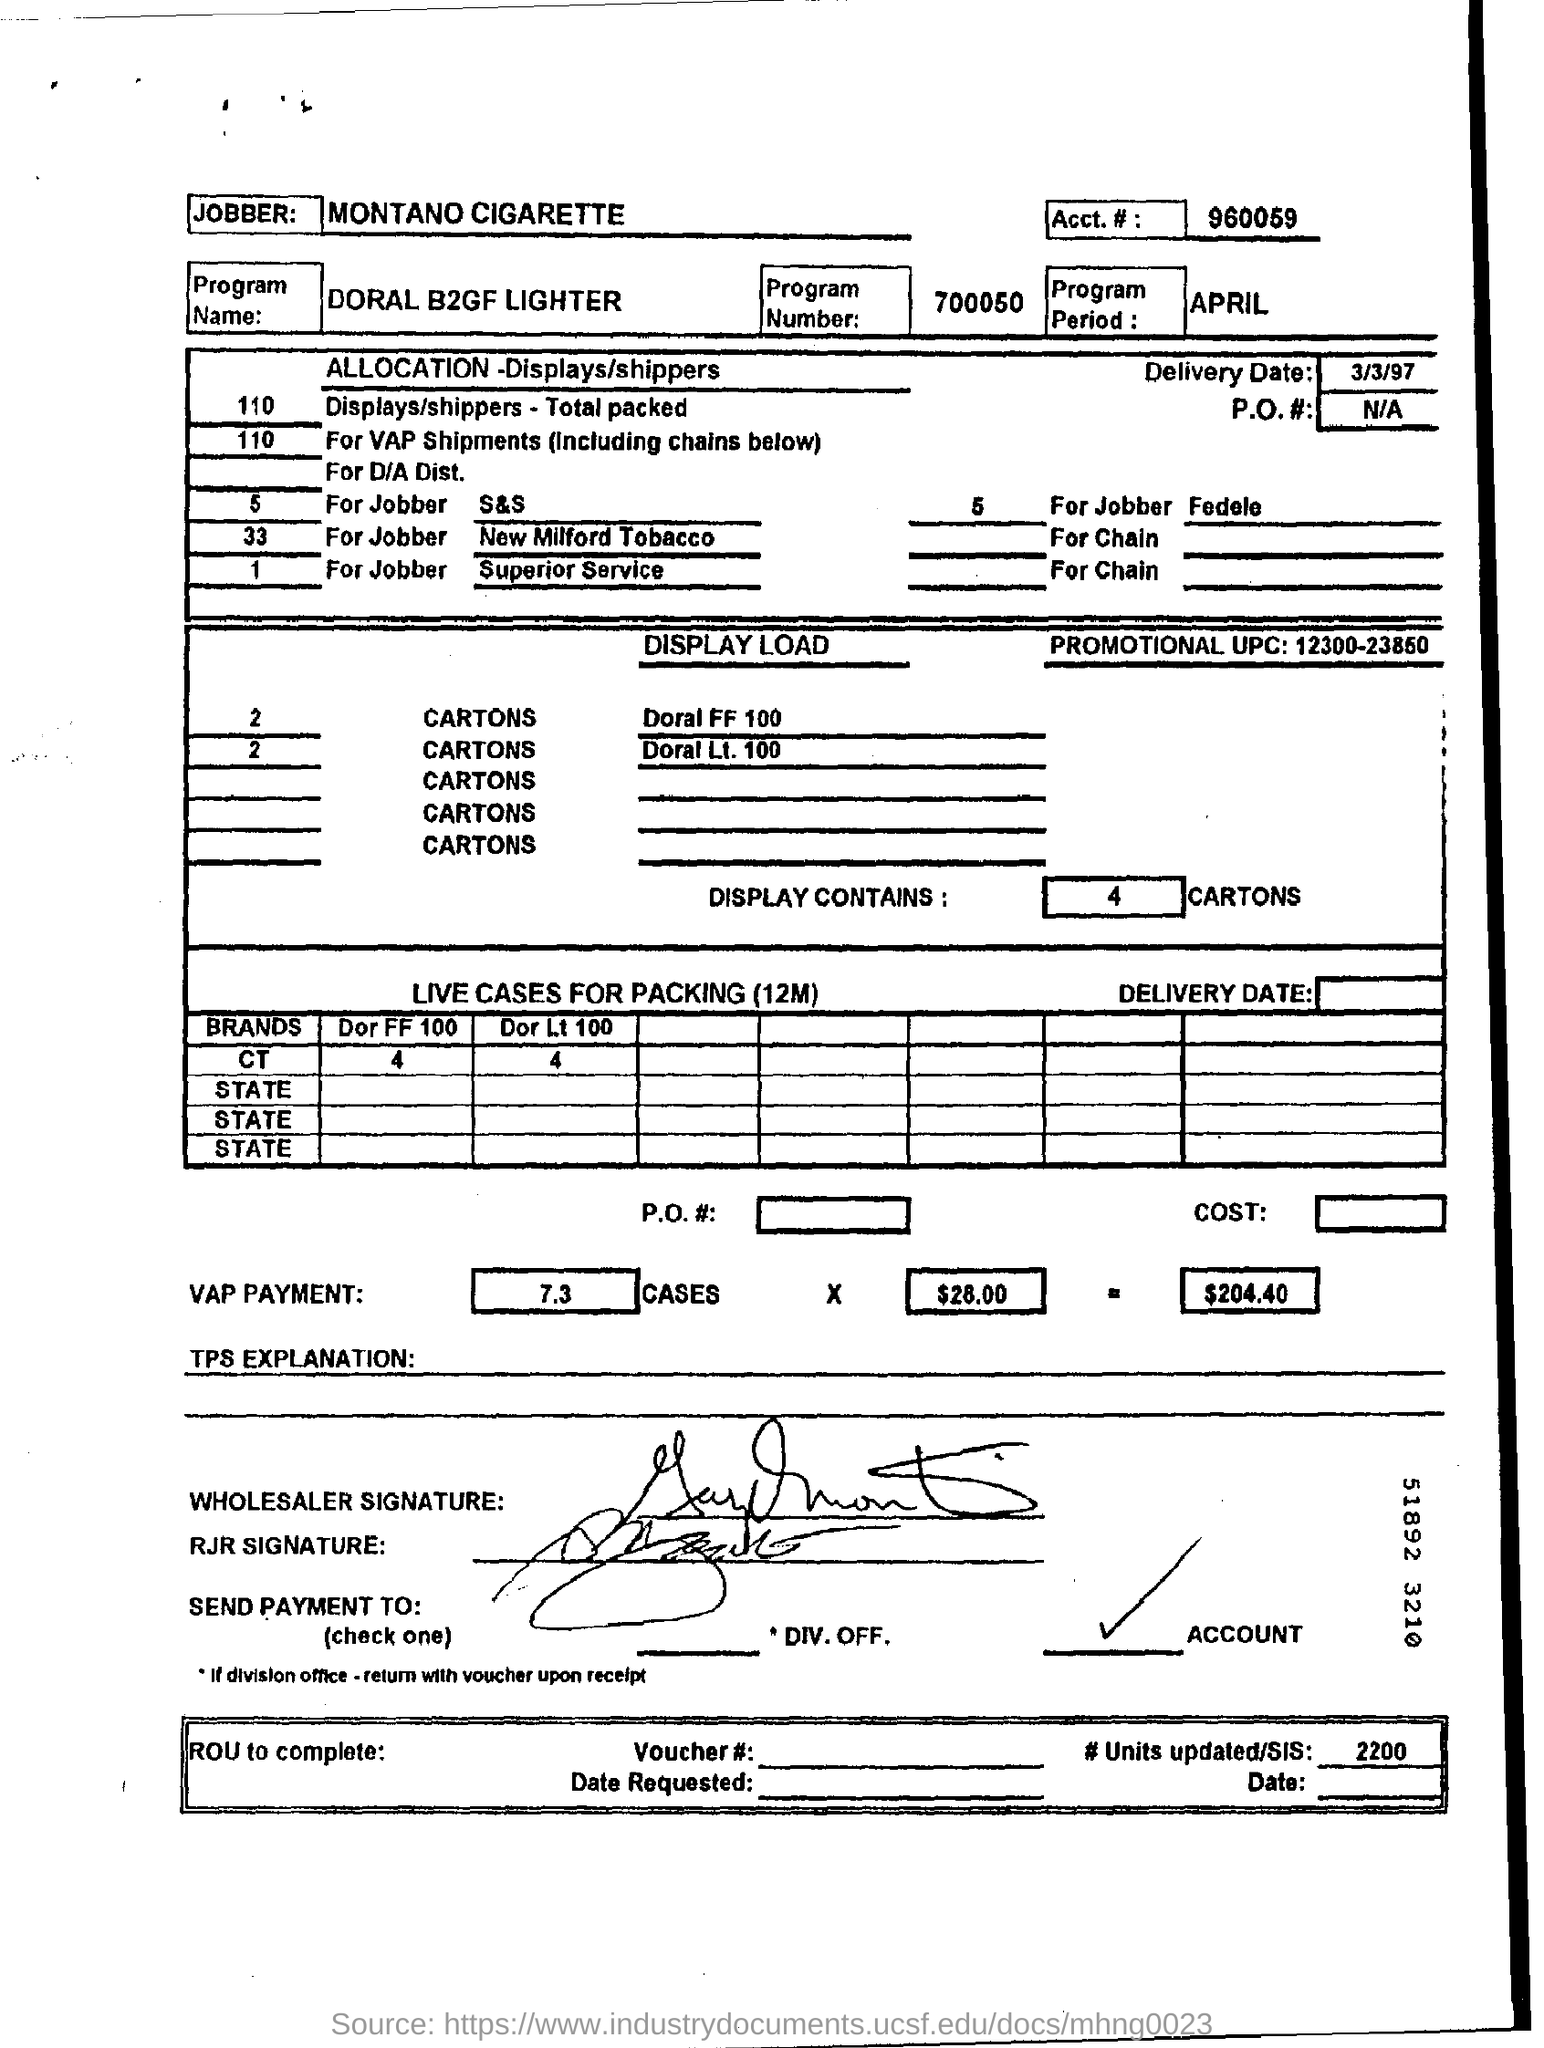Identify some key points in this picture. The named program is "Doral B2GF Lighter. The program period for April has not been specified. Mention the delivery date of March 3, 1997. The display contains 4 cartons. 